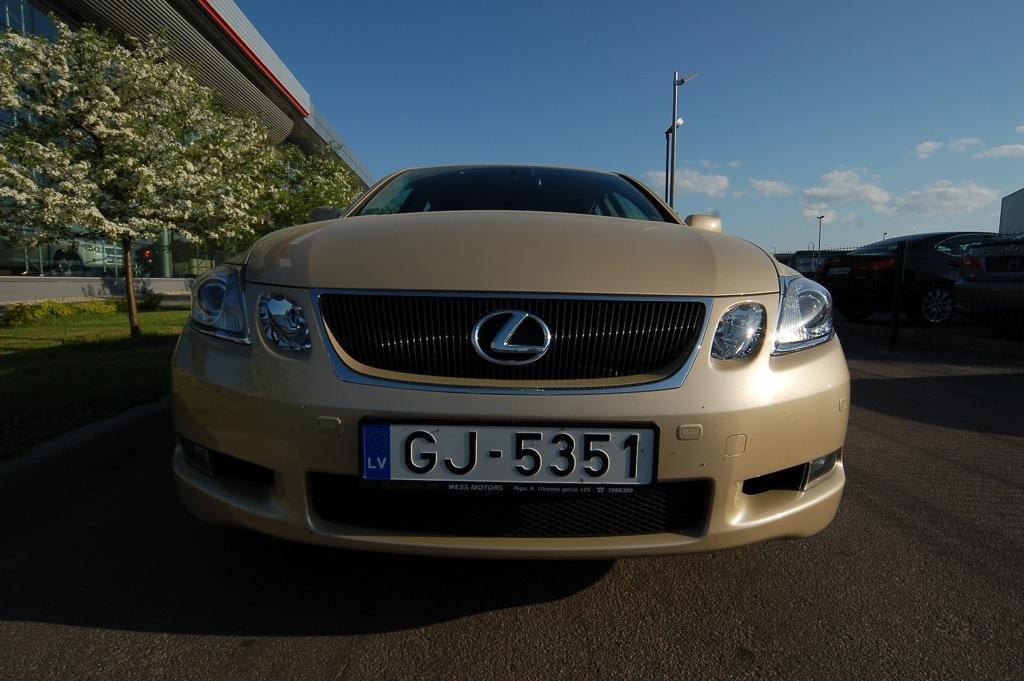How would you summarize this image in a sentence or two? In the picture we can see a front part of the car with a number GJ-5351 and beside it, we can see a grass surface with some plants and part of the building with glasses from it, we can see a car and behind the car we can see a pole and the sky with clouds. 